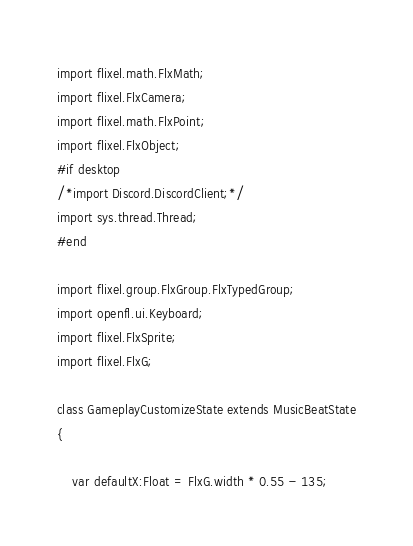Convert code to text. <code><loc_0><loc_0><loc_500><loc_500><_Haxe_>import flixel.math.FlxMath;
import flixel.FlxCamera;
import flixel.math.FlxPoint;
import flixel.FlxObject;
#if desktop
/*import Discord.DiscordClient;*/
import sys.thread.Thread;
#end

import flixel.group.FlxGroup.FlxTypedGroup;
import openfl.ui.Keyboard;
import flixel.FlxSprite;
import flixel.FlxG;

class GameplayCustomizeState extends MusicBeatState
{

    var defaultX:Float = FlxG.width * 0.55 - 135;</code> 